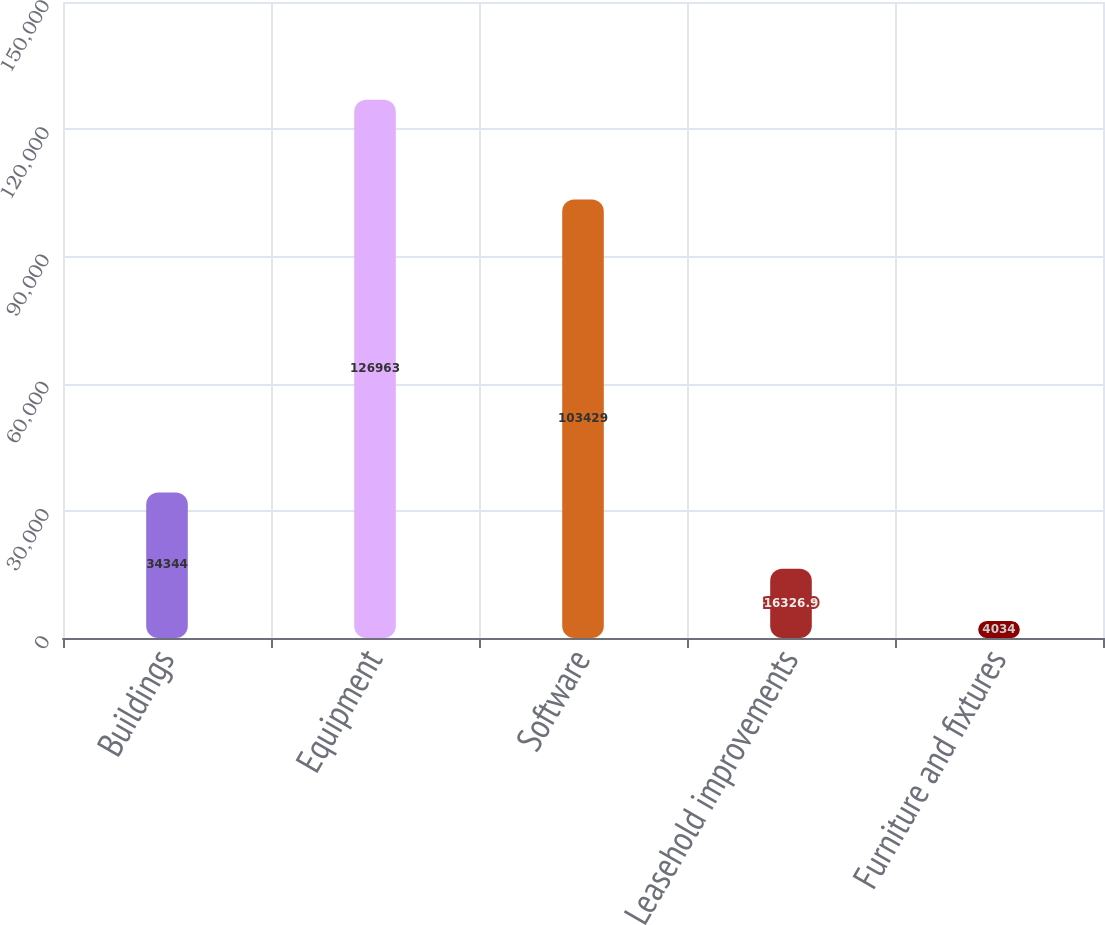Convert chart. <chart><loc_0><loc_0><loc_500><loc_500><bar_chart><fcel>Buildings<fcel>Equipment<fcel>Software<fcel>Leasehold improvements<fcel>Furniture and fixtures<nl><fcel>34344<fcel>126963<fcel>103429<fcel>16326.9<fcel>4034<nl></chart> 